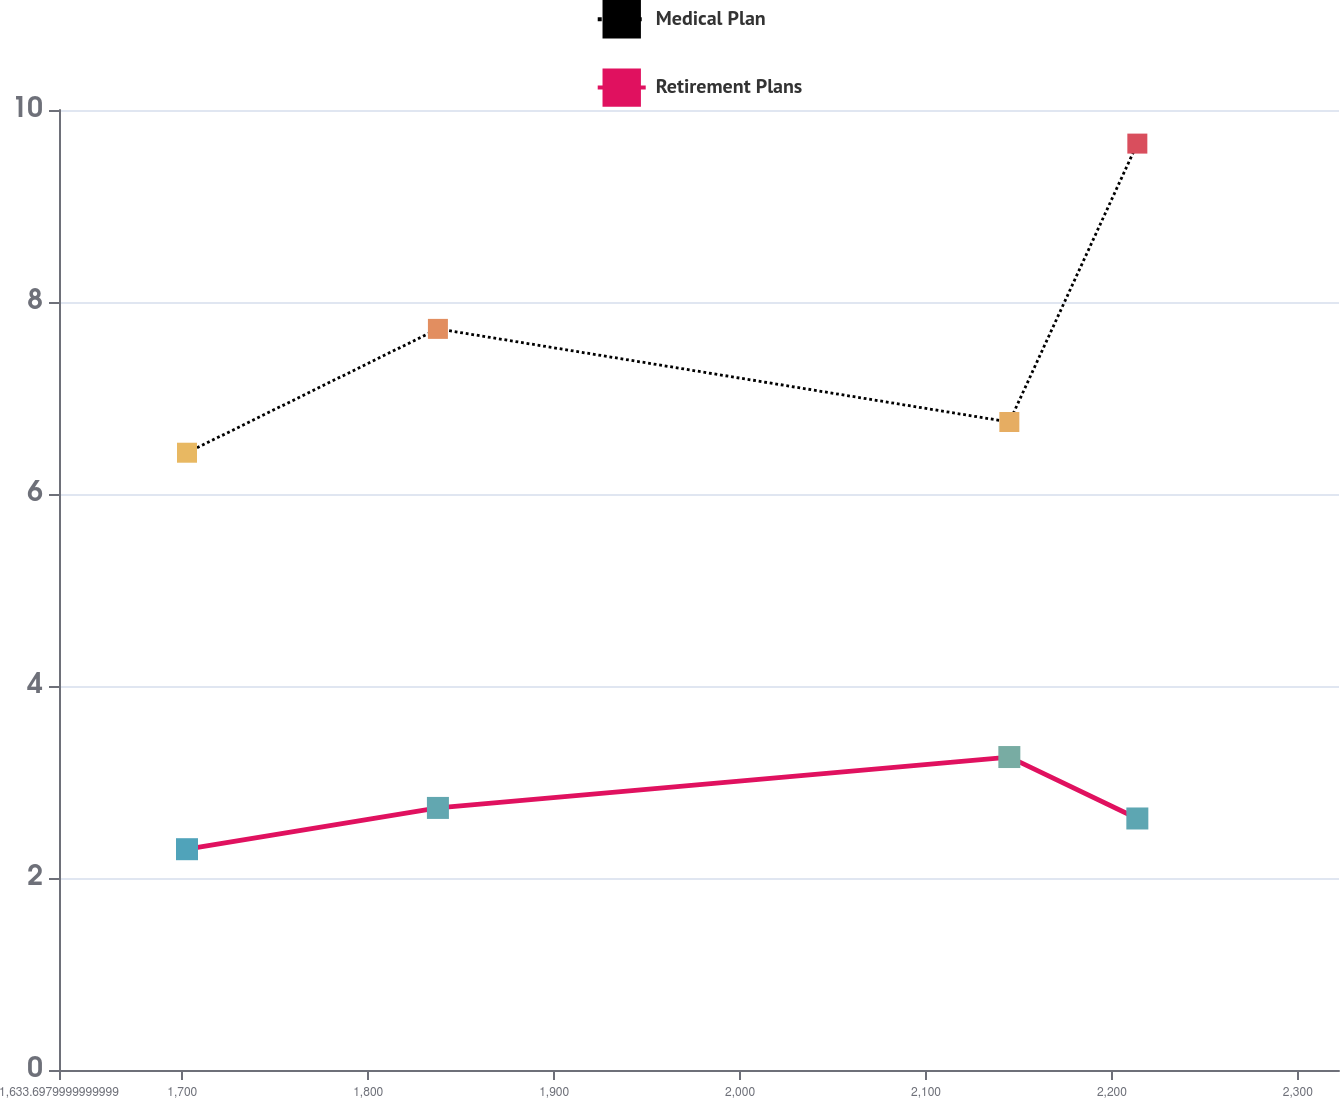Convert chart. <chart><loc_0><loc_0><loc_500><loc_500><line_chart><ecel><fcel>Medical Plan<fcel>Retirement Plans<nl><fcel>1702.54<fcel>6.43<fcel>2.3<nl><fcel>1837.49<fcel>7.72<fcel>2.73<nl><fcel>2144.82<fcel>6.75<fcel>3.26<nl><fcel>2213.66<fcel>9.65<fcel>2.62<nl><fcel>2390.96<fcel>8.62<fcel>3.44<nl></chart> 